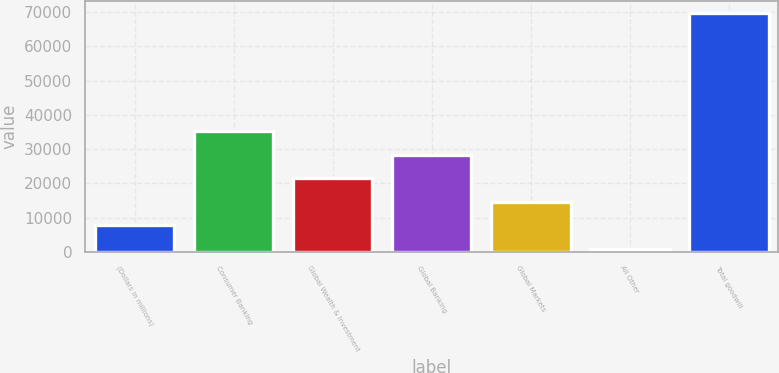<chart> <loc_0><loc_0><loc_500><loc_500><bar_chart><fcel>(Dollars in millions)<fcel>Consumer Banking<fcel>Global Wealth & Investment<fcel>Global Banking<fcel>Global Markets<fcel>All Other<fcel>Total goodwill<nl><fcel>7714.1<fcel>35290.5<fcel>21502.3<fcel>28396.4<fcel>14608.2<fcel>820<fcel>69761<nl></chart> 